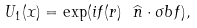<formula> <loc_0><loc_0><loc_500><loc_500>U _ { 1 } ( { x } ) = \exp ( i f ( r ) \ \widehat { n } \cdot \sigma b f ) ,</formula> 